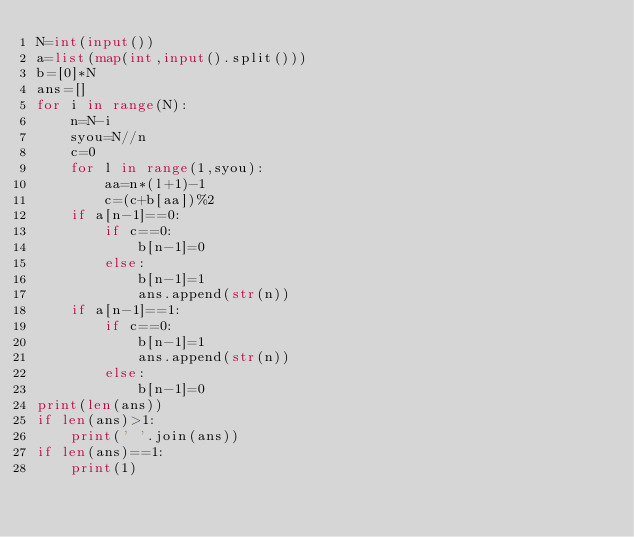Convert code to text. <code><loc_0><loc_0><loc_500><loc_500><_Python_>N=int(input())
a=list(map(int,input().split()))
b=[0]*N
ans=[]
for i in range(N):
    n=N-i
    syou=N//n
    c=0
    for l in range(1,syou):
        aa=n*(l+1)-1
        c=(c+b[aa])%2
    if a[n-1]==0:
        if c==0:
            b[n-1]=0
        else:
            b[n-1]=1
            ans.append(str(n))
    if a[n-1]==1:
        if c==0:
            b[n-1]=1
            ans.append(str(n))
        else:
            b[n-1]=0
print(len(ans))
if len(ans)>1:
    print(' '.join(ans))
if len(ans)==1:
    print(1)
</code> 